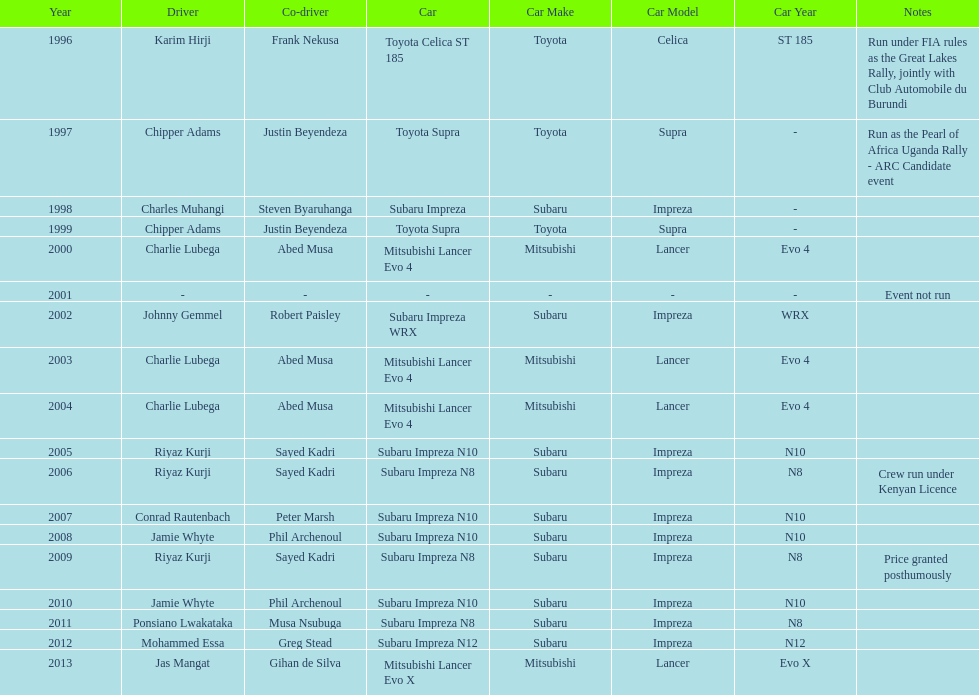Which driver won after ponsiano lwakataka? Mohammed Essa. 